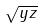<formula> <loc_0><loc_0><loc_500><loc_500>\sqrt { y z }</formula> 